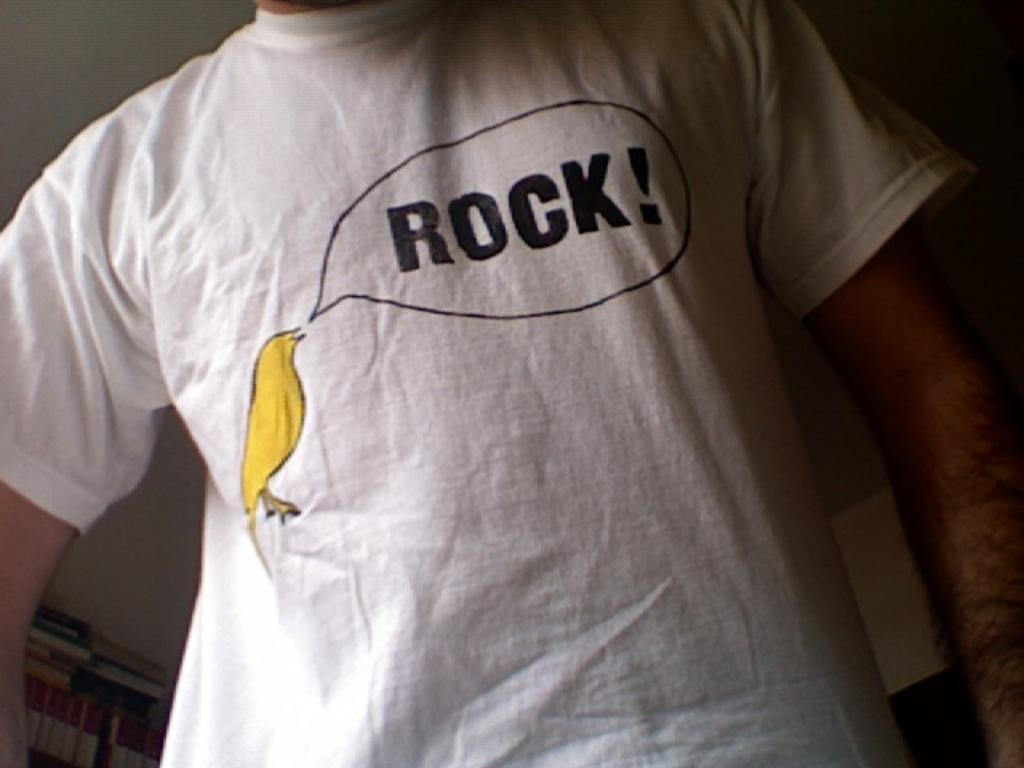<image>
Render a clear and concise summary of the photo. A white T shirt has a yellow canary saying, "Rock" on it, 